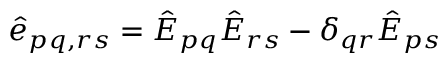<formula> <loc_0><loc_0><loc_500><loc_500>\hat { e } _ { p q , r s } = \hat { E } _ { p q } \hat { E } _ { r s } - \delta _ { q r } \hat { E } _ { p s }</formula> 